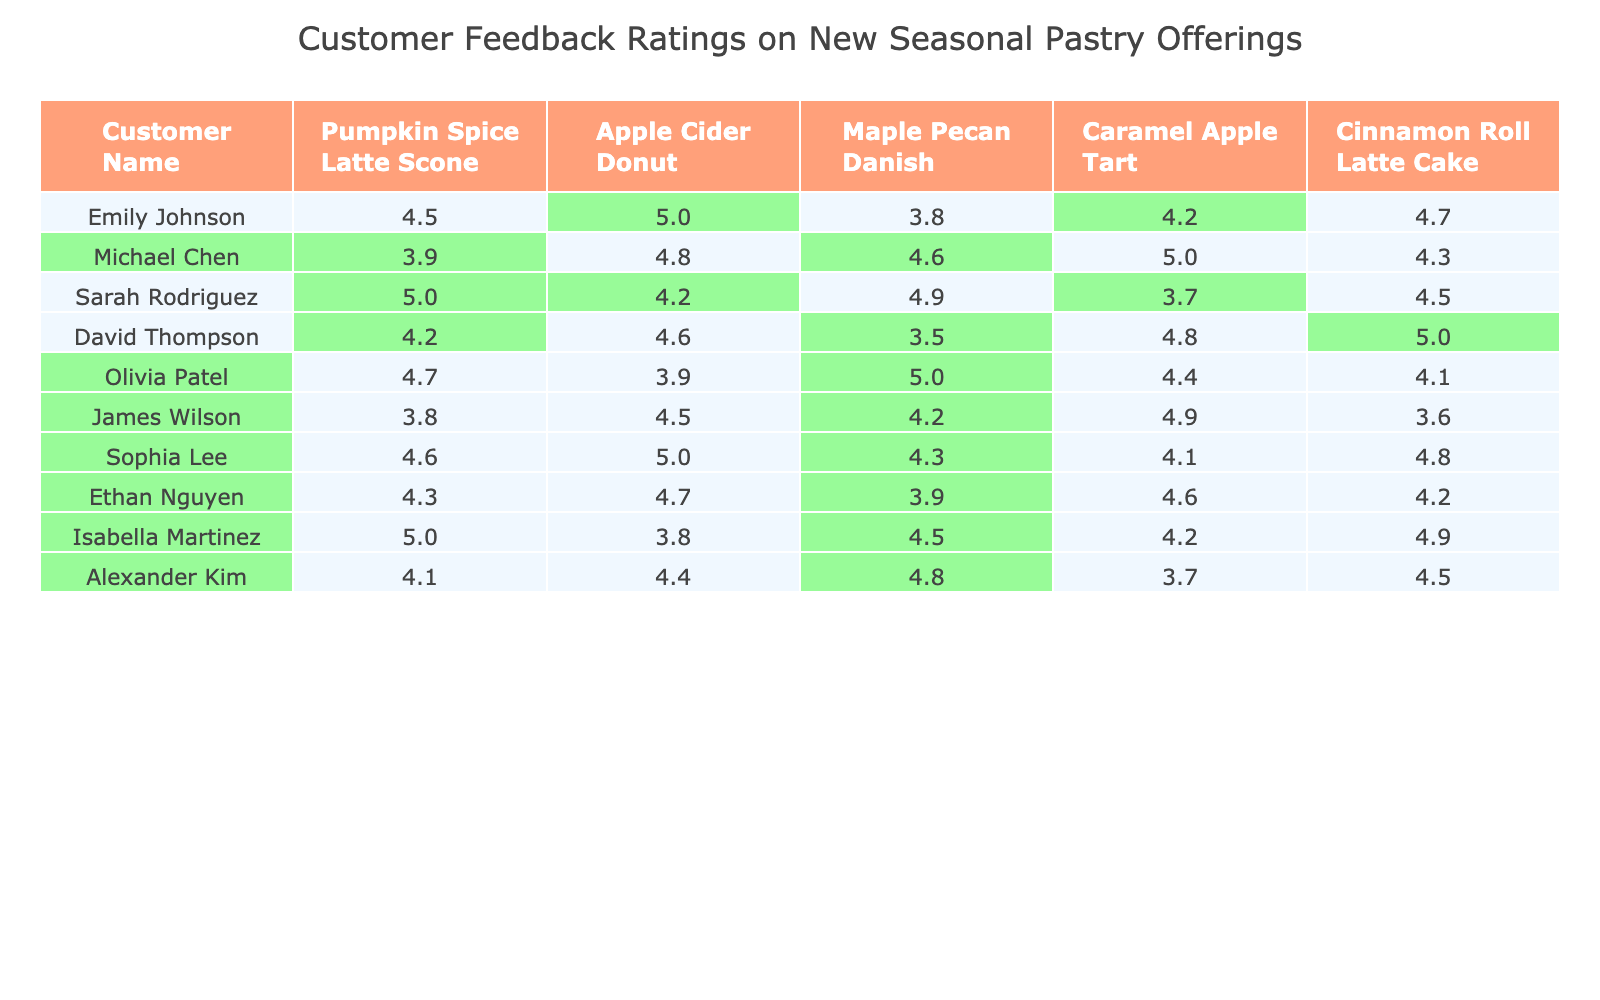What is the highest rating given to the Maple Pecan Danish? By reviewing the ratings for the Maple Pecan Danish across all customers, the highest rating is given by Sarah Rodriguez, which is 4.9.
Answer: 4.9 Which customer rated the Cinnamon Roll Latte Cake the highest? Looking at the ratings for the Cinnamon Roll Latte Cake, David Thompson gave it the highest rating of 5.
Answer: David Thompson What is the average rating for the Apple Cider Donut? To find the average rating, sum all ratings for the Apple Cider Donut (5 + 4.8 + 4.2 + 4.6 + 3.9 + 4.5 + 5 + 4.7 + 3.8 + 4.4) which equals 48.6, and then divide by 10 (number of customer ratings) resulting in an average of 4.86.
Answer: 4.86 Did Michael Chen rate any pastry below 4? After checking the ratings given by Michael Chen, the only pastry rated below 4 is the Pumpkin Spice Latte Scone, which received a rating of 3.9.
Answer: Yes Which pastry received the most ratings above 4.5? By counting the ratings above 4.5 for each pastry, the Caramel Apple Tart received 6 ratings above 4.5, making it the one with the most high ratings compared to the others.
Answer: Caramel Apple Tart What is the difference between the highest and lowest rating for the Cinnamon Roll Latte Cake? The highest rating for the Cinnamon Roll Latte Cake is 5 (David Thompson) and the lowest rating is 3.6 (James Wilson). The difference is 5 - 3.6 = 1.4.
Answer: 1.4 Which customer had the lowest average rating across all pastries? To solve this, calculate the average for each customer: James Wilson has the lowest average rating when calculated as (3.8 + 4.5 + 4.2 + 4.9 + 3.6) = 20.0, then average that by 5, resulting in an average of 4.0.
Answer: James Wilson How many customers rated the Pumpkin Spice Latte Scone above 4.5? Reviewing the ratings, the customers who rated the Pumpkin Spice Latte Scone above 4.5 are Sarah Rodriguez, Olivia Patel, Sophia Lee, and Ethan Nguyen, totaling 4 customers.
Answer: 4 What percentage of customers rated the Maple Pecan Danish above 4? There are 10 customers total and 6 rated the Maple Pecan Danish above 4 (Michael Chen, Sarah Rodriguez, Alexander Kim, Isabella Martinez, etc.). The percentage is (6/10) * 100 = 60%.
Answer: 60% What is the median rating for the Caramel Apple Tart? To find the median, list ratings for the Caramel Apple Tart (4.2, 5, 3.7, 4.8, 4.4, 4.9, 4.1, and 4.6) in ascending order: (3.7, 4.1, 4.2, 4.4, 4.6, 4.8, 4.9, 5). The median of these 8 ratings (middle two values) is the average of 4.4 and 4.6 which is 4.5.
Answer: 4.5 